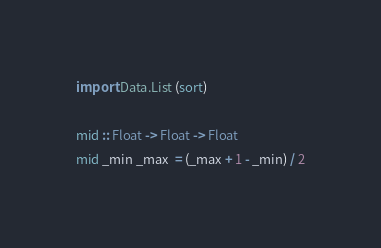<code> <loc_0><loc_0><loc_500><loc_500><_Haskell_>import Data.List (sort)

mid :: Float -> Float -> Float
mid _min _max  = (_max + 1 - _min) / 2
</code> 